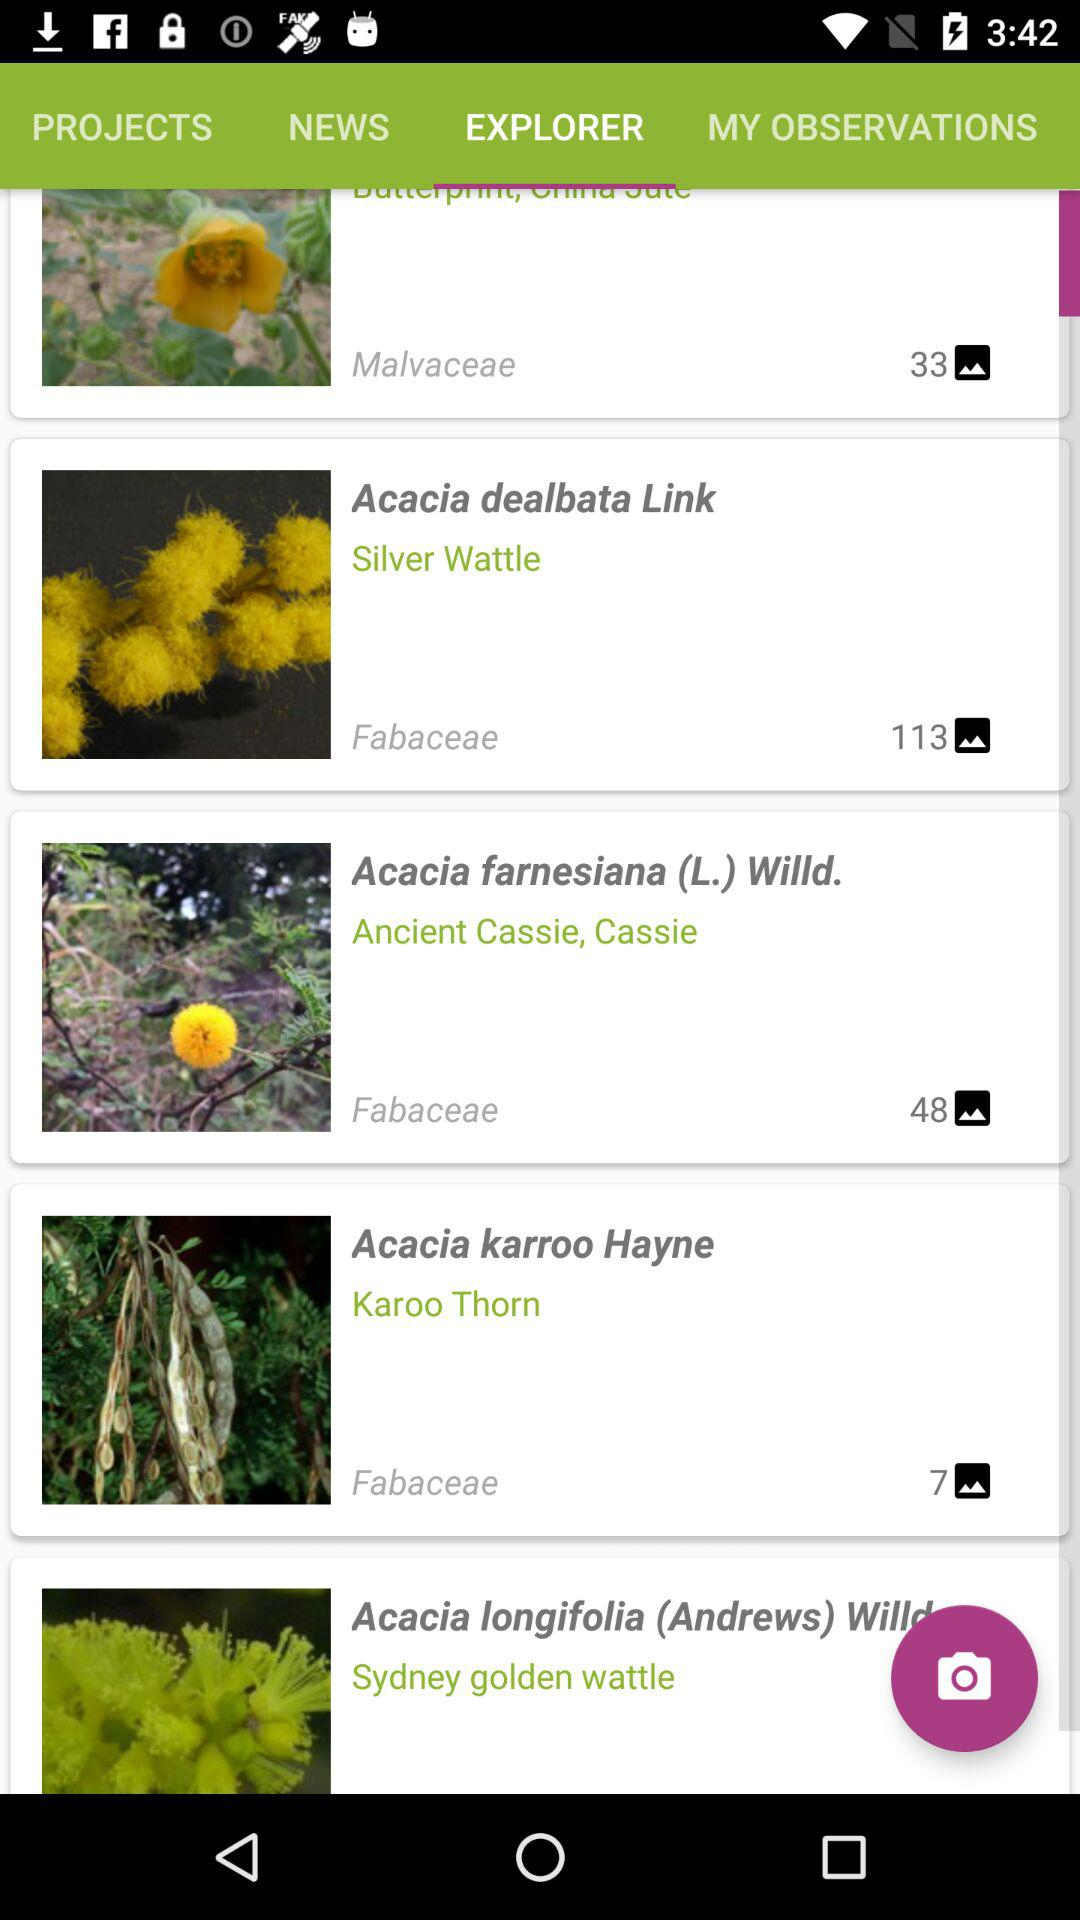How many more Fabaceae plants are there than Malvaceae plants?
Answer the question using a single word or phrase. 2 